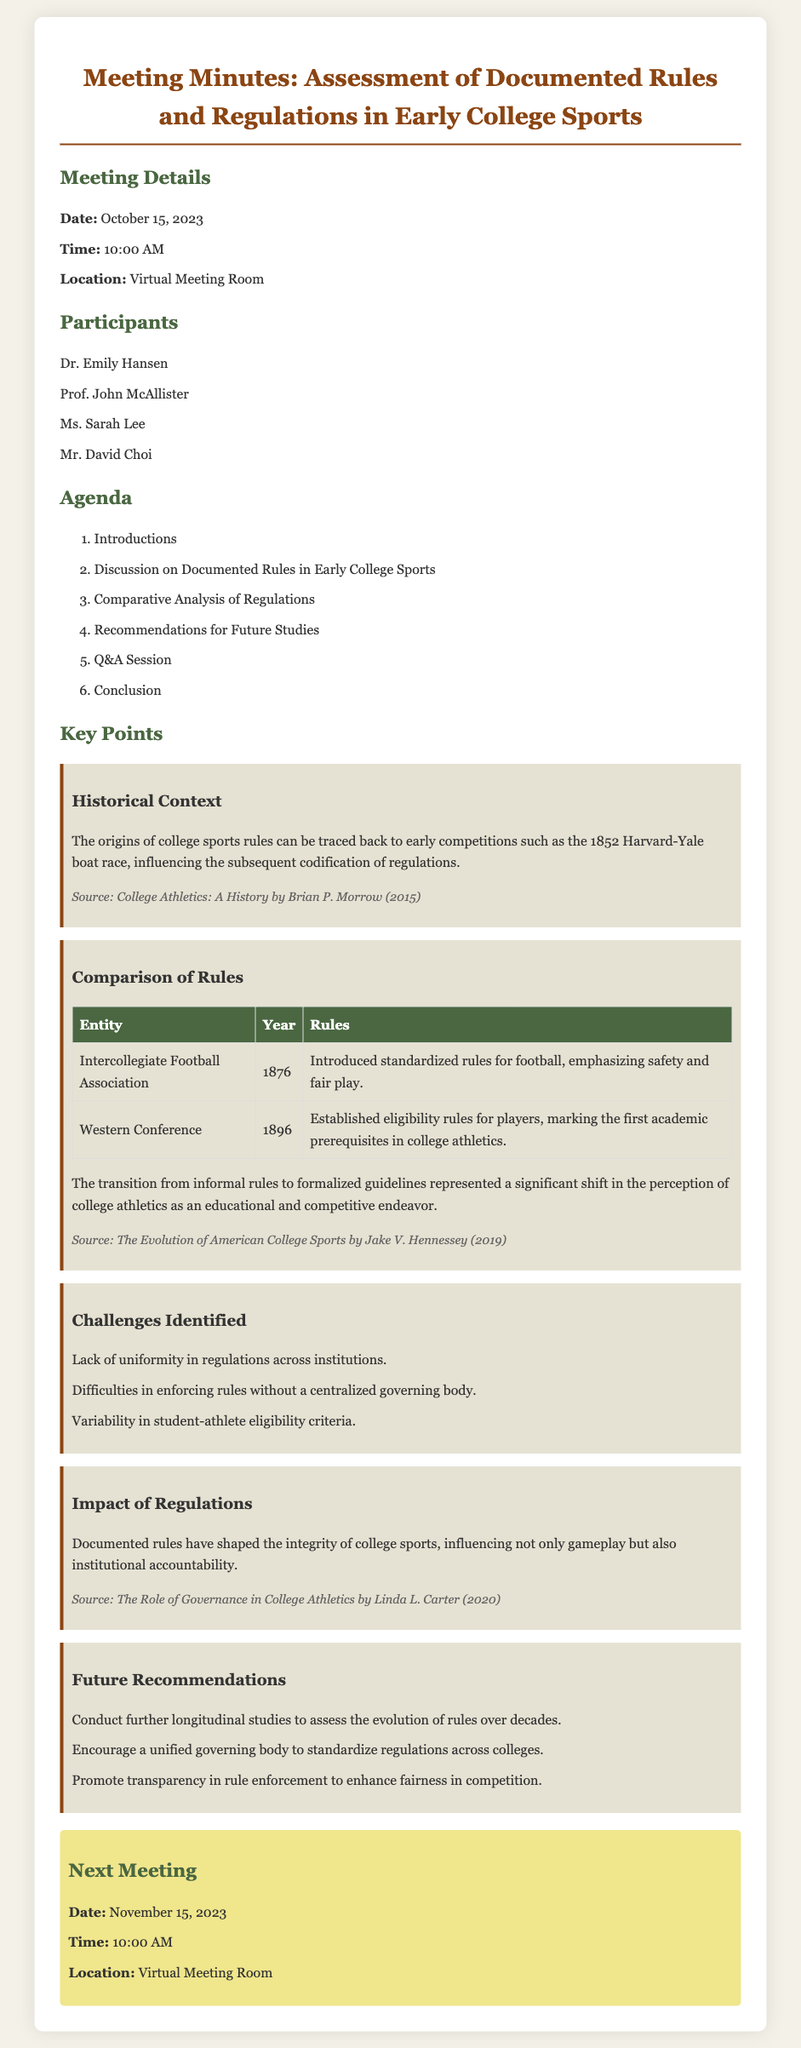What is the date of the meeting? The date of the meeting is mentioned in the Meeting Details section.
Answer: October 15, 2023 Who is one of the participants in the meeting? The participants are listed in the Participants section, providing specific names.
Answer: Dr. Emily Hansen What was a key historical event influencing college sports rules? The key historical context is detailed in the meeting minutes, specifically noting an early competition.
Answer: 1852 Harvard-Yale boat race What year did the Intercollegiate Football Association introduce standardized rules? The year is found in the Comparison of Rules table, which documents specific entities and their respective years.
Answer: 1876 What challenge was identified regarding regulations? The challenges are listed under the Challenges Identified section.
Answer: Lack of uniformity What is one future recommendation from the meeting? Future recommendations are outlined, and one can be cited as an example from the relevant section.
Answer: Conduct further longitudinal studies What document type does this content represent? This content is structured as a formal record, specifically associated with meeting activities.
Answer: Meeting minutes 